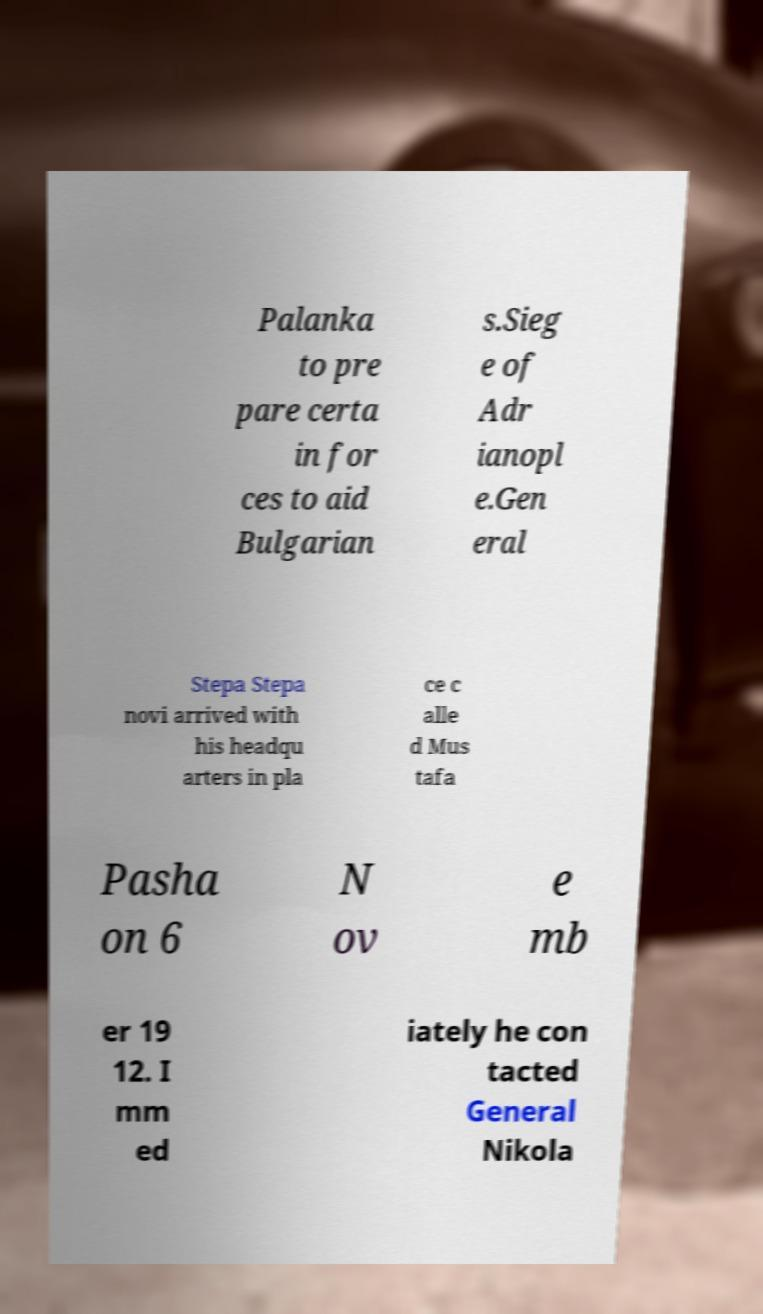For documentation purposes, I need the text within this image transcribed. Could you provide that? Palanka to pre pare certa in for ces to aid Bulgarian s.Sieg e of Adr ianopl e.Gen eral Stepa Stepa novi arrived with his headqu arters in pla ce c alle d Mus tafa Pasha on 6 N ov e mb er 19 12. I mm ed iately he con tacted General Nikola 